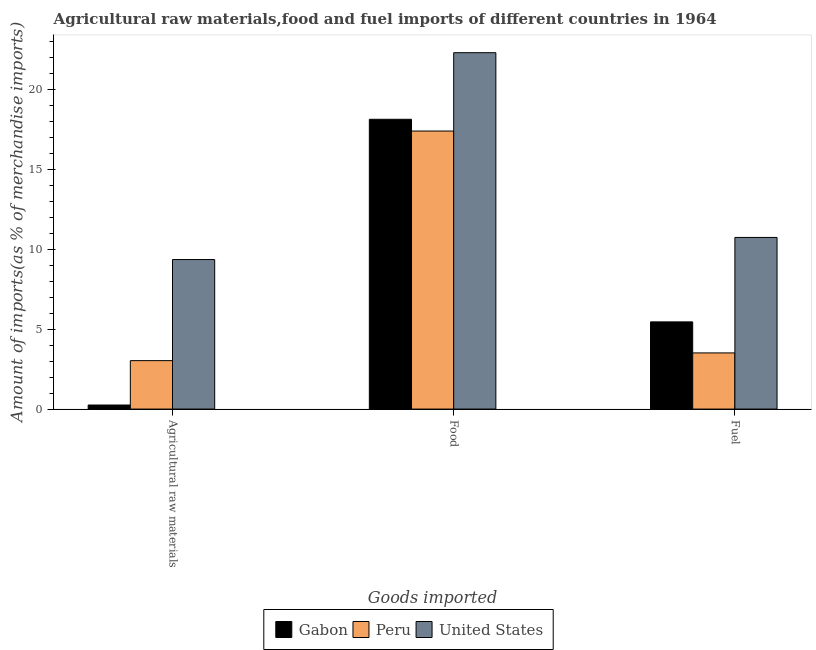How many groups of bars are there?
Ensure brevity in your answer.  3. Are the number of bars per tick equal to the number of legend labels?
Provide a short and direct response. Yes. How many bars are there on the 1st tick from the right?
Give a very brief answer. 3. What is the label of the 1st group of bars from the left?
Your response must be concise. Agricultural raw materials. What is the percentage of raw materials imports in United States?
Your answer should be compact. 9.35. Across all countries, what is the maximum percentage of raw materials imports?
Your answer should be very brief. 9.35. Across all countries, what is the minimum percentage of food imports?
Keep it short and to the point. 17.39. What is the total percentage of food imports in the graph?
Offer a terse response. 57.79. What is the difference between the percentage of food imports in Gabon and that in Peru?
Your answer should be compact. 0.73. What is the difference between the percentage of raw materials imports in Peru and the percentage of fuel imports in Gabon?
Give a very brief answer. -2.42. What is the average percentage of fuel imports per country?
Your response must be concise. 6.57. What is the difference between the percentage of raw materials imports and percentage of food imports in Peru?
Give a very brief answer. -14.36. In how many countries, is the percentage of raw materials imports greater than 21 %?
Offer a terse response. 0. What is the ratio of the percentage of raw materials imports in Gabon to that in United States?
Offer a very short reply. 0.03. Is the difference between the percentage of food imports in Peru and United States greater than the difference between the percentage of raw materials imports in Peru and United States?
Provide a short and direct response. Yes. What is the difference between the highest and the second highest percentage of raw materials imports?
Make the answer very short. 6.32. What is the difference between the highest and the lowest percentage of fuel imports?
Provide a succinct answer. 7.22. What does the 1st bar from the left in Fuel represents?
Offer a terse response. Gabon. How many bars are there?
Keep it short and to the point. 9. Are all the bars in the graph horizontal?
Offer a very short reply. No. How many countries are there in the graph?
Your answer should be compact. 3. What is the difference between two consecutive major ticks on the Y-axis?
Your response must be concise. 5. Are the values on the major ticks of Y-axis written in scientific E-notation?
Provide a short and direct response. No. Does the graph contain any zero values?
Provide a short and direct response. No. Does the graph contain grids?
Your answer should be very brief. No. What is the title of the graph?
Ensure brevity in your answer.  Agricultural raw materials,food and fuel imports of different countries in 1964. What is the label or title of the X-axis?
Your answer should be compact. Goods imported. What is the label or title of the Y-axis?
Your answer should be very brief. Amount of imports(as % of merchandise imports). What is the Amount of imports(as % of merchandise imports) of Gabon in Agricultural raw materials?
Your answer should be compact. 0.25. What is the Amount of imports(as % of merchandise imports) in Peru in Agricultural raw materials?
Offer a terse response. 3.03. What is the Amount of imports(as % of merchandise imports) in United States in Agricultural raw materials?
Offer a very short reply. 9.35. What is the Amount of imports(as % of merchandise imports) of Gabon in Food?
Offer a very short reply. 18.12. What is the Amount of imports(as % of merchandise imports) of Peru in Food?
Offer a very short reply. 17.39. What is the Amount of imports(as % of merchandise imports) in United States in Food?
Your response must be concise. 22.28. What is the Amount of imports(as % of merchandise imports) of Gabon in Fuel?
Ensure brevity in your answer.  5.45. What is the Amount of imports(as % of merchandise imports) in Peru in Fuel?
Make the answer very short. 3.51. What is the Amount of imports(as % of merchandise imports) in United States in Fuel?
Give a very brief answer. 10.73. Across all Goods imported, what is the maximum Amount of imports(as % of merchandise imports) of Gabon?
Offer a terse response. 18.12. Across all Goods imported, what is the maximum Amount of imports(as % of merchandise imports) of Peru?
Provide a succinct answer. 17.39. Across all Goods imported, what is the maximum Amount of imports(as % of merchandise imports) in United States?
Ensure brevity in your answer.  22.28. Across all Goods imported, what is the minimum Amount of imports(as % of merchandise imports) of Gabon?
Provide a succinct answer. 0.25. Across all Goods imported, what is the minimum Amount of imports(as % of merchandise imports) of Peru?
Offer a terse response. 3.03. Across all Goods imported, what is the minimum Amount of imports(as % of merchandise imports) in United States?
Offer a terse response. 9.35. What is the total Amount of imports(as % of merchandise imports) in Gabon in the graph?
Provide a short and direct response. 23.83. What is the total Amount of imports(as % of merchandise imports) of Peru in the graph?
Offer a very short reply. 23.93. What is the total Amount of imports(as % of merchandise imports) in United States in the graph?
Make the answer very short. 42.37. What is the difference between the Amount of imports(as % of merchandise imports) in Gabon in Agricultural raw materials and that in Food?
Offer a very short reply. -17.87. What is the difference between the Amount of imports(as % of merchandise imports) of Peru in Agricultural raw materials and that in Food?
Offer a very short reply. -14.36. What is the difference between the Amount of imports(as % of merchandise imports) of United States in Agricultural raw materials and that in Food?
Offer a terse response. -12.93. What is the difference between the Amount of imports(as % of merchandise imports) of Gabon in Agricultural raw materials and that in Fuel?
Provide a short and direct response. -5.2. What is the difference between the Amount of imports(as % of merchandise imports) in Peru in Agricultural raw materials and that in Fuel?
Your response must be concise. -0.48. What is the difference between the Amount of imports(as % of merchandise imports) in United States in Agricultural raw materials and that in Fuel?
Offer a terse response. -1.38. What is the difference between the Amount of imports(as % of merchandise imports) in Gabon in Food and that in Fuel?
Your response must be concise. 12.67. What is the difference between the Amount of imports(as % of merchandise imports) in Peru in Food and that in Fuel?
Provide a short and direct response. 13.87. What is the difference between the Amount of imports(as % of merchandise imports) in United States in Food and that in Fuel?
Ensure brevity in your answer.  11.55. What is the difference between the Amount of imports(as % of merchandise imports) of Gabon in Agricultural raw materials and the Amount of imports(as % of merchandise imports) of Peru in Food?
Make the answer very short. -17.13. What is the difference between the Amount of imports(as % of merchandise imports) of Gabon in Agricultural raw materials and the Amount of imports(as % of merchandise imports) of United States in Food?
Give a very brief answer. -22.03. What is the difference between the Amount of imports(as % of merchandise imports) of Peru in Agricultural raw materials and the Amount of imports(as % of merchandise imports) of United States in Food?
Keep it short and to the point. -19.25. What is the difference between the Amount of imports(as % of merchandise imports) in Gabon in Agricultural raw materials and the Amount of imports(as % of merchandise imports) in Peru in Fuel?
Offer a terse response. -3.26. What is the difference between the Amount of imports(as % of merchandise imports) in Gabon in Agricultural raw materials and the Amount of imports(as % of merchandise imports) in United States in Fuel?
Your answer should be compact. -10.48. What is the difference between the Amount of imports(as % of merchandise imports) of Peru in Agricultural raw materials and the Amount of imports(as % of merchandise imports) of United States in Fuel?
Provide a succinct answer. -7.7. What is the difference between the Amount of imports(as % of merchandise imports) of Gabon in Food and the Amount of imports(as % of merchandise imports) of Peru in Fuel?
Provide a short and direct response. 14.61. What is the difference between the Amount of imports(as % of merchandise imports) in Gabon in Food and the Amount of imports(as % of merchandise imports) in United States in Fuel?
Offer a very short reply. 7.39. What is the difference between the Amount of imports(as % of merchandise imports) of Peru in Food and the Amount of imports(as % of merchandise imports) of United States in Fuel?
Provide a succinct answer. 6.65. What is the average Amount of imports(as % of merchandise imports) of Gabon per Goods imported?
Keep it short and to the point. 7.94. What is the average Amount of imports(as % of merchandise imports) of Peru per Goods imported?
Offer a terse response. 7.98. What is the average Amount of imports(as % of merchandise imports) in United States per Goods imported?
Provide a succinct answer. 14.12. What is the difference between the Amount of imports(as % of merchandise imports) of Gabon and Amount of imports(as % of merchandise imports) of Peru in Agricultural raw materials?
Your answer should be very brief. -2.78. What is the difference between the Amount of imports(as % of merchandise imports) of Gabon and Amount of imports(as % of merchandise imports) of United States in Agricultural raw materials?
Keep it short and to the point. -9.1. What is the difference between the Amount of imports(as % of merchandise imports) of Peru and Amount of imports(as % of merchandise imports) of United States in Agricultural raw materials?
Keep it short and to the point. -6.32. What is the difference between the Amount of imports(as % of merchandise imports) in Gabon and Amount of imports(as % of merchandise imports) in Peru in Food?
Your answer should be very brief. 0.73. What is the difference between the Amount of imports(as % of merchandise imports) of Gabon and Amount of imports(as % of merchandise imports) of United States in Food?
Provide a succinct answer. -4.16. What is the difference between the Amount of imports(as % of merchandise imports) of Peru and Amount of imports(as % of merchandise imports) of United States in Food?
Give a very brief answer. -4.9. What is the difference between the Amount of imports(as % of merchandise imports) of Gabon and Amount of imports(as % of merchandise imports) of Peru in Fuel?
Your answer should be very brief. 1.94. What is the difference between the Amount of imports(as % of merchandise imports) in Gabon and Amount of imports(as % of merchandise imports) in United States in Fuel?
Give a very brief answer. -5.28. What is the difference between the Amount of imports(as % of merchandise imports) of Peru and Amount of imports(as % of merchandise imports) of United States in Fuel?
Offer a terse response. -7.22. What is the ratio of the Amount of imports(as % of merchandise imports) in Gabon in Agricultural raw materials to that in Food?
Your answer should be compact. 0.01. What is the ratio of the Amount of imports(as % of merchandise imports) in Peru in Agricultural raw materials to that in Food?
Keep it short and to the point. 0.17. What is the ratio of the Amount of imports(as % of merchandise imports) of United States in Agricultural raw materials to that in Food?
Make the answer very short. 0.42. What is the ratio of the Amount of imports(as % of merchandise imports) in Gabon in Agricultural raw materials to that in Fuel?
Provide a short and direct response. 0.05. What is the ratio of the Amount of imports(as % of merchandise imports) of Peru in Agricultural raw materials to that in Fuel?
Your answer should be very brief. 0.86. What is the ratio of the Amount of imports(as % of merchandise imports) in United States in Agricultural raw materials to that in Fuel?
Give a very brief answer. 0.87. What is the ratio of the Amount of imports(as % of merchandise imports) of Gabon in Food to that in Fuel?
Give a very brief answer. 3.32. What is the ratio of the Amount of imports(as % of merchandise imports) in Peru in Food to that in Fuel?
Offer a very short reply. 4.95. What is the ratio of the Amount of imports(as % of merchandise imports) of United States in Food to that in Fuel?
Your answer should be very brief. 2.08. What is the difference between the highest and the second highest Amount of imports(as % of merchandise imports) of Gabon?
Offer a terse response. 12.67. What is the difference between the highest and the second highest Amount of imports(as % of merchandise imports) in Peru?
Offer a very short reply. 13.87. What is the difference between the highest and the second highest Amount of imports(as % of merchandise imports) in United States?
Offer a very short reply. 11.55. What is the difference between the highest and the lowest Amount of imports(as % of merchandise imports) in Gabon?
Your response must be concise. 17.87. What is the difference between the highest and the lowest Amount of imports(as % of merchandise imports) of Peru?
Your response must be concise. 14.36. What is the difference between the highest and the lowest Amount of imports(as % of merchandise imports) of United States?
Provide a succinct answer. 12.93. 